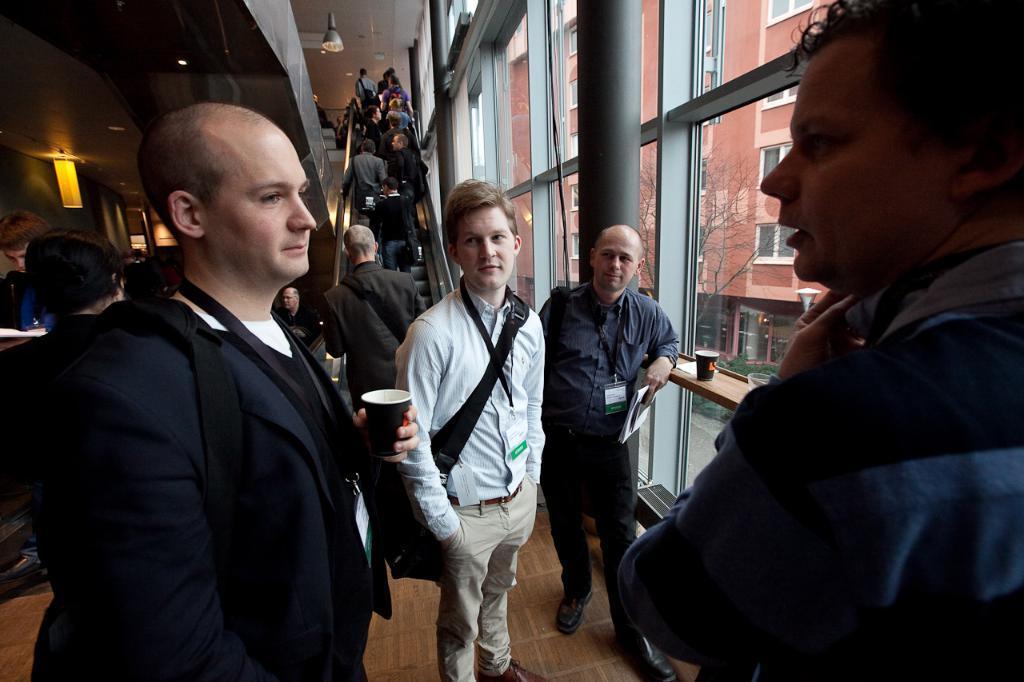In one or two sentences, can you explain what this image depicts? In this image we can see many people. There are two buildings in the image. There are few lamps, a tree and a street lamp in the image. A person is holding a glass at the left side of the image and a person is holding an object at the right side of the image. 